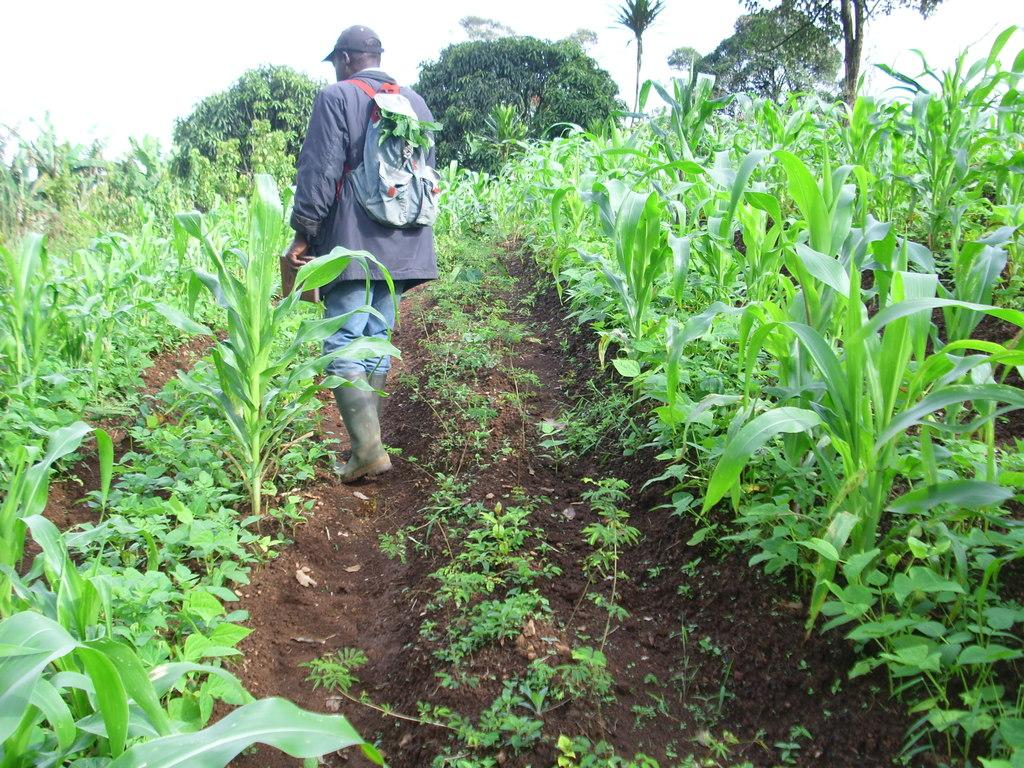What is present in the image? There is a person in the image. What is the person holding? The person is holding an object. What type of vegetation is around the person? There are plants around the person. What can be seen behind the person? There is a group of trees behind the person. What is visible at the top of the image? The sky is visible at the top of the image. What type of berry is the person eating in the image? There is no berry present in the image, and the person is not eating anything. 